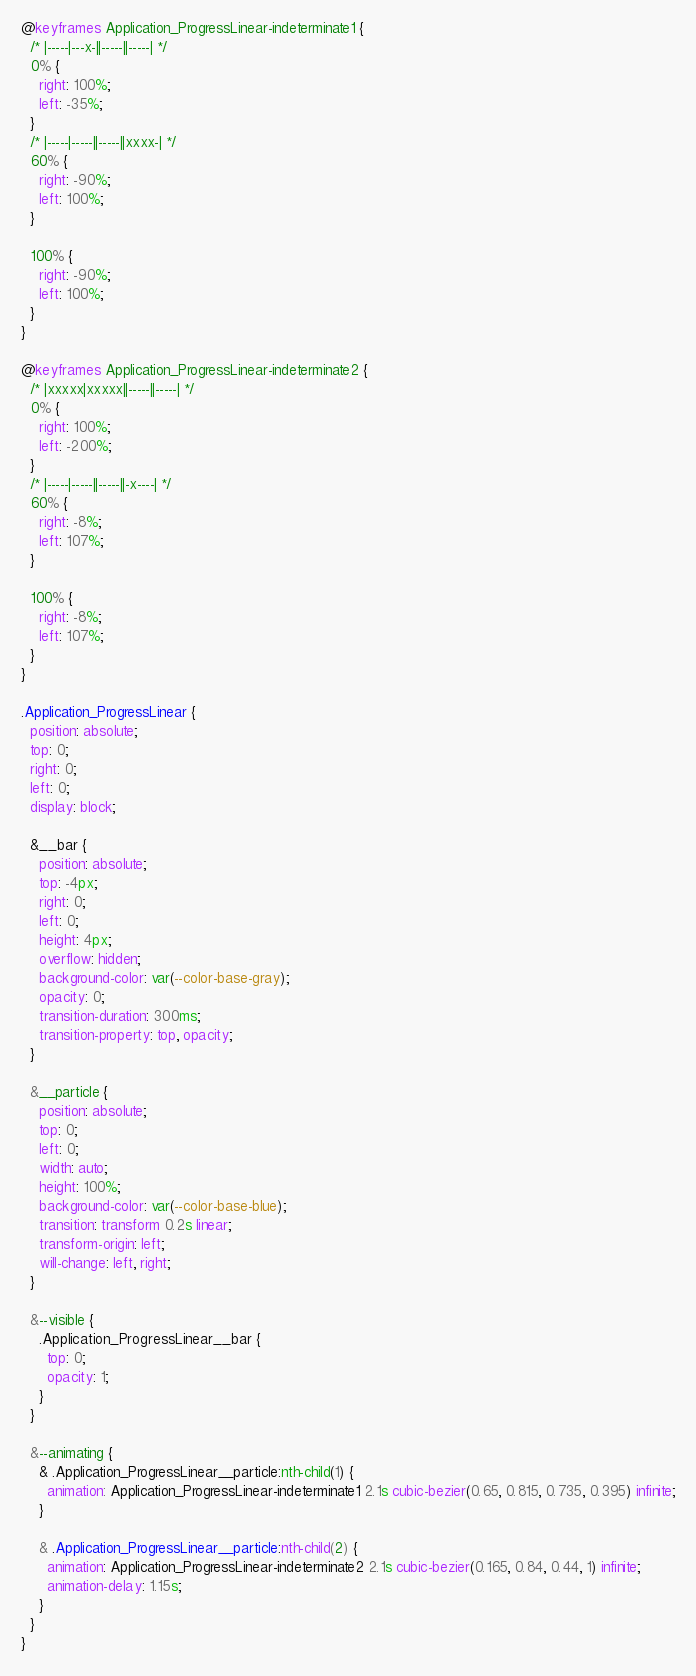Convert code to text. <code><loc_0><loc_0><loc_500><loc_500><_CSS_>@keyframes Application_ProgressLinear-indeterminate1 {
  /* |-----|---x-||-----||-----| */
  0% {
    right: 100%;
    left: -35%;
  }
  /* |-----|-----||-----||xxxx-| */
  60% {
    right: -90%;
    left: 100%;
  }

  100% {
    right: -90%;
    left: 100%;
  }
}

@keyframes Application_ProgressLinear-indeterminate2 {
  /* |xxxxx|xxxxx||-----||-----| */
  0% {
    right: 100%;
    left: -200%;
  }
  /* |-----|-----||-----||-x----| */
  60% {
    right: -8%;
    left: 107%;
  }

  100% {
    right: -8%;
    left: 107%;
  }
}

.Application_ProgressLinear {
  position: absolute;
  top: 0;
  right: 0;
  left: 0;
  display: block;

  &__bar {
    position: absolute;
    top: -4px;
    right: 0;
    left: 0;
    height: 4px;
    overflow: hidden;
    background-color: var(--color-base-gray);
    opacity: 0;
    transition-duration: 300ms;
    transition-property: top, opacity;
  }

  &__particle {
    position: absolute;
    top: 0;
    left: 0;
    width: auto;
    height: 100%;
    background-color: var(--color-base-blue);
    transition: transform 0.2s linear;
    transform-origin: left;
    will-change: left, right;
  }

  &--visible {
    .Application_ProgressLinear__bar {
      top: 0;
      opacity: 1;
    }
  }

  &--animating {
    & .Application_ProgressLinear__particle:nth-child(1) {
      animation: Application_ProgressLinear-indeterminate1 2.1s cubic-bezier(0.65, 0.815, 0.735, 0.395) infinite;
    }

    & .Application_ProgressLinear__particle:nth-child(2) {
      animation: Application_ProgressLinear-indeterminate2 2.1s cubic-bezier(0.165, 0.84, 0.44, 1) infinite;
      animation-delay: 1.15s;
    }
  }
}
</code> 